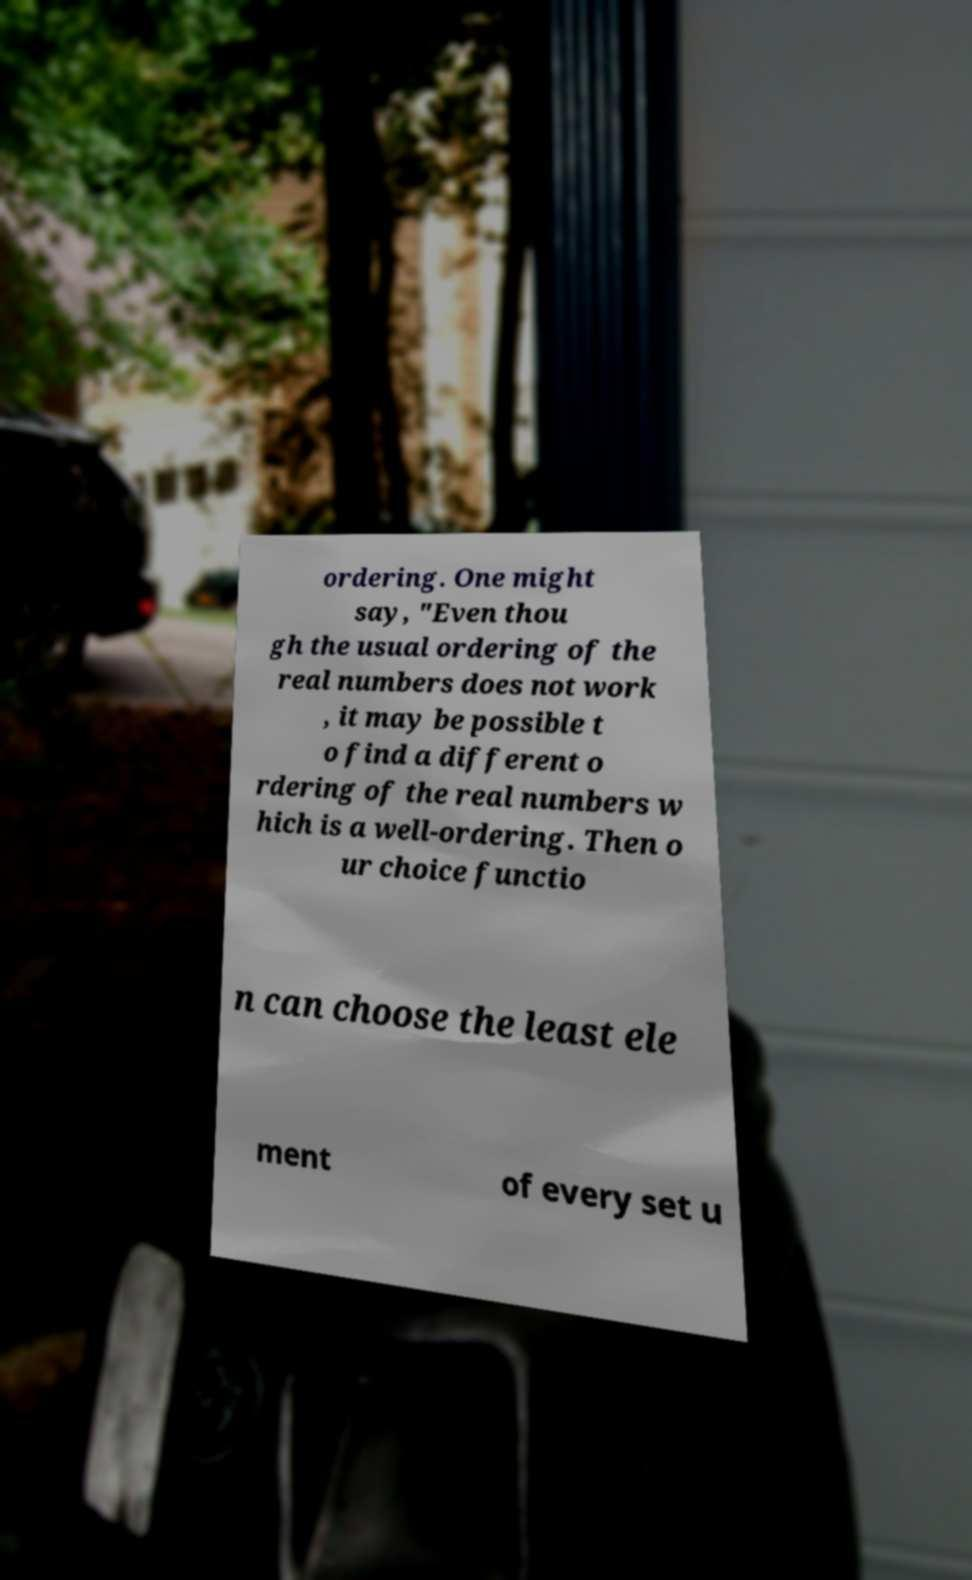Please identify and transcribe the text found in this image. ordering. One might say, "Even thou gh the usual ordering of the real numbers does not work , it may be possible t o find a different o rdering of the real numbers w hich is a well-ordering. Then o ur choice functio n can choose the least ele ment of every set u 